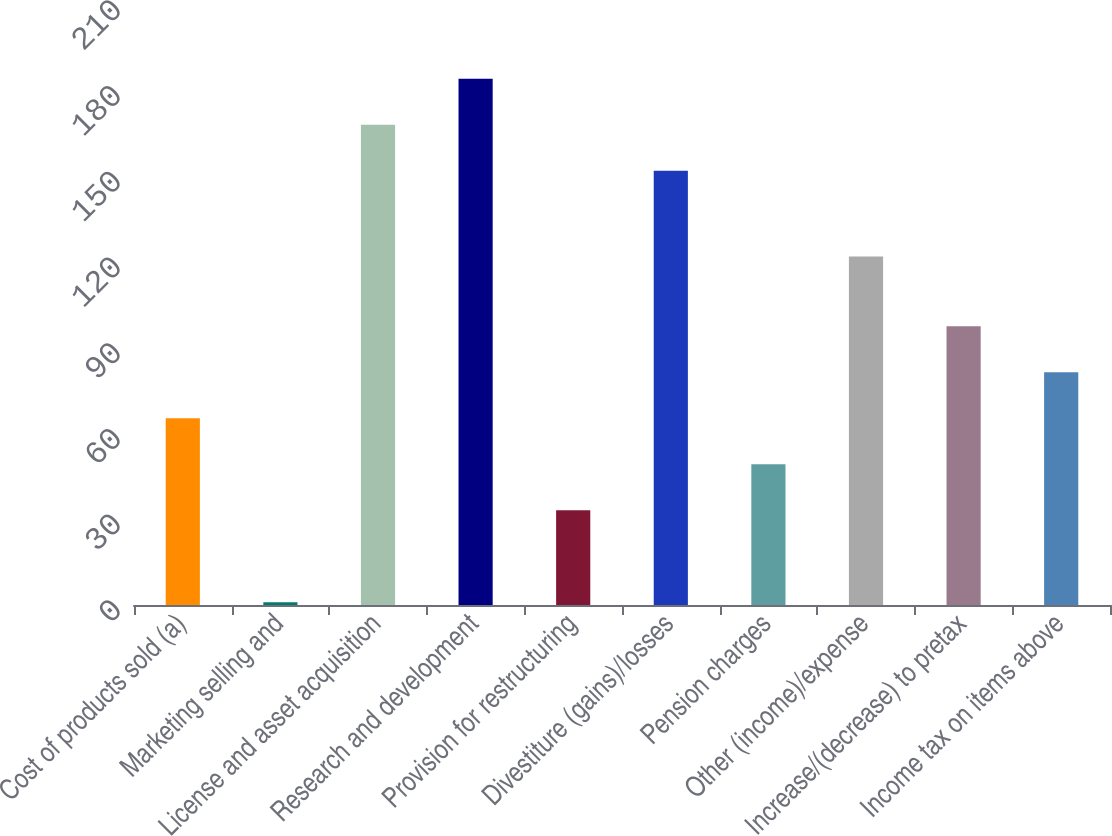<chart> <loc_0><loc_0><loc_500><loc_500><bar_chart><fcel>Cost of products sold (a)<fcel>Marketing selling and<fcel>License and asset acquisition<fcel>Research and development<fcel>Provision for restructuring<fcel>Divestiture (gains)/losses<fcel>Pension charges<fcel>Other (income)/expense<fcel>Increase/(decrease) to pretax<fcel>Income tax on items above<nl><fcel>65.4<fcel>1<fcel>168.1<fcel>184.2<fcel>33.2<fcel>152<fcel>49.3<fcel>122<fcel>97.6<fcel>81.5<nl></chart> 